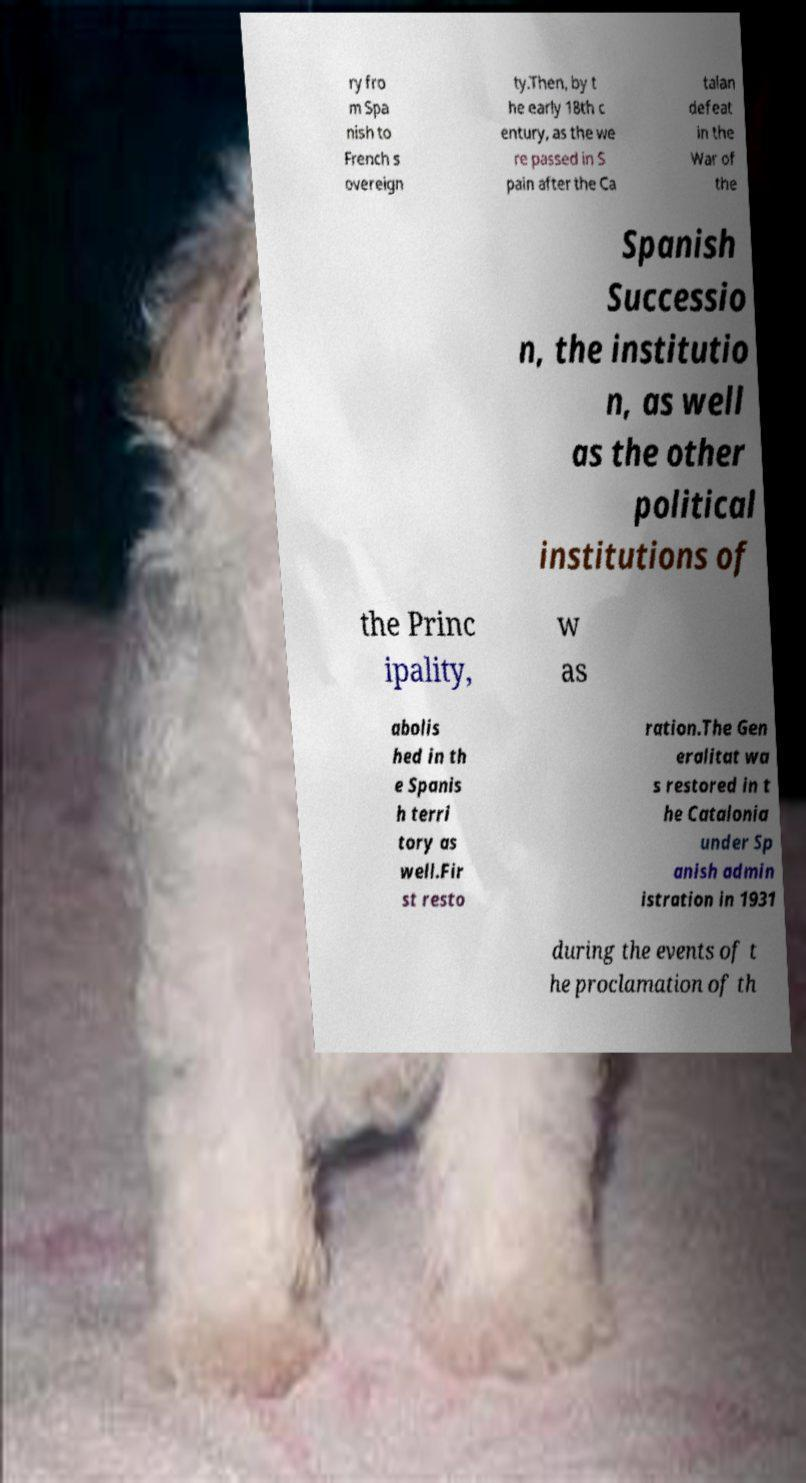Please identify and transcribe the text found in this image. ry fro m Spa nish to French s overeign ty.Then, by t he early 18th c entury, as the we re passed in S pain after the Ca talan defeat in the War of the Spanish Successio n, the institutio n, as well as the other political institutions of the Princ ipality, w as abolis hed in th e Spanis h terri tory as well.Fir st resto ration.The Gen eralitat wa s restored in t he Catalonia under Sp anish admin istration in 1931 during the events of t he proclamation of th 